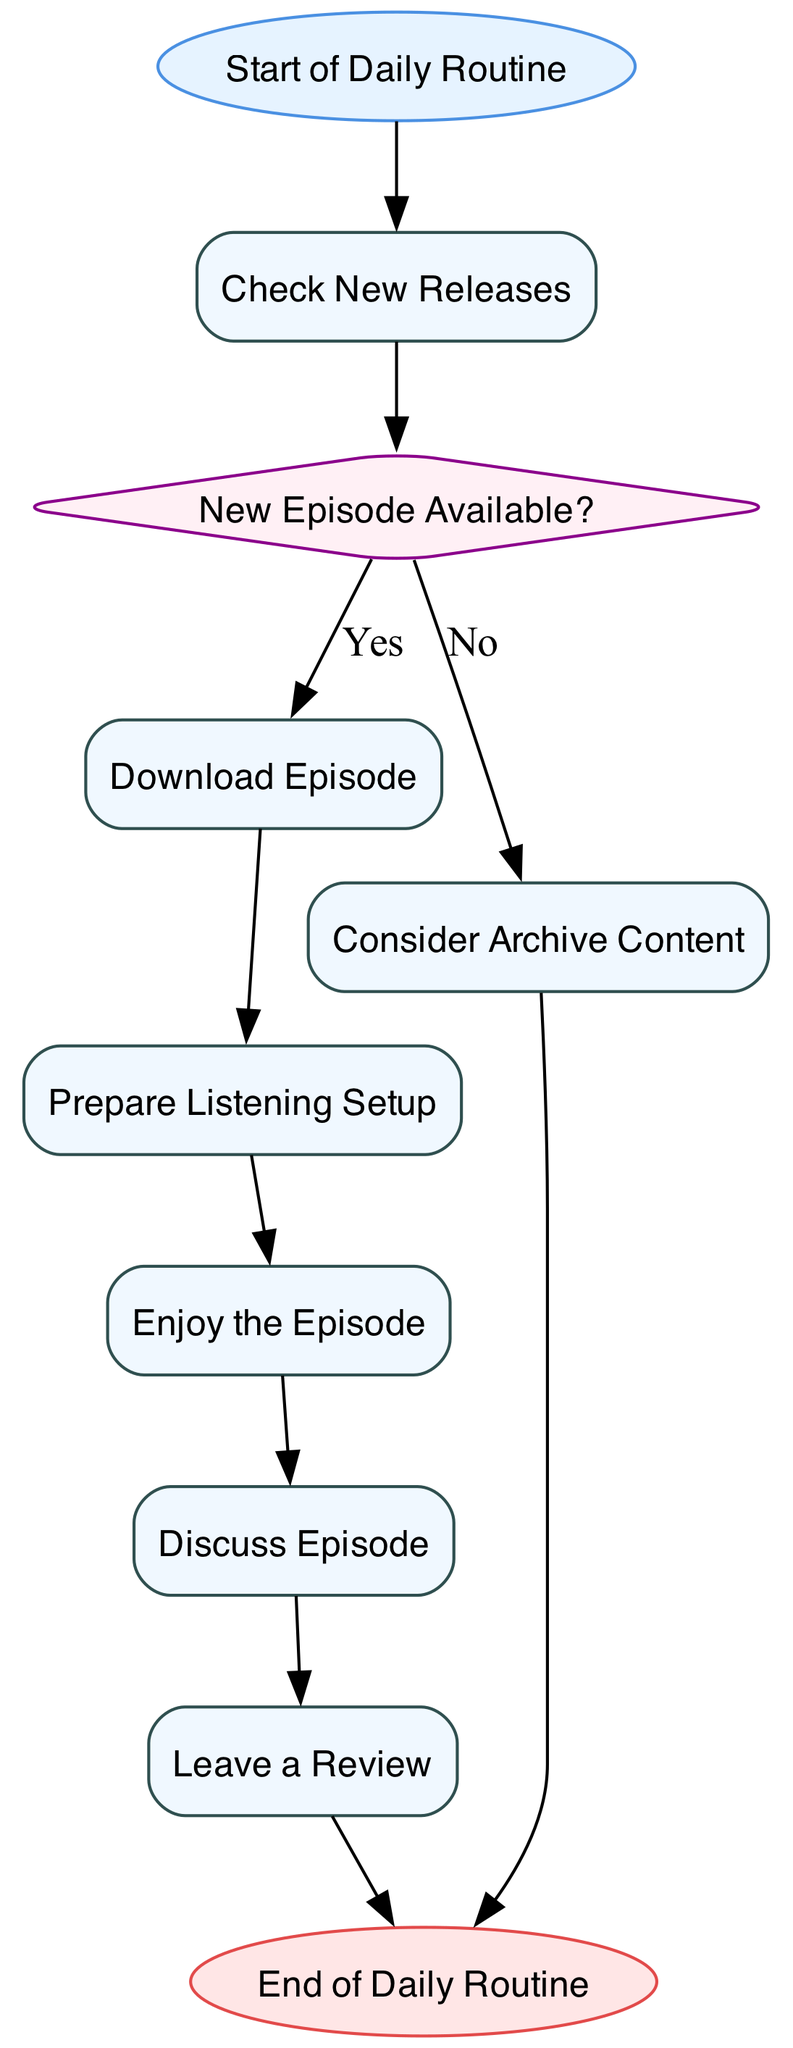What is the first action in the daily routine? The diagram starts with the first action node labeled "Check New Releases," which follows the start node labeled "Start of Daily Routine."
Answer: Check New Releases How many action nodes are present in the diagram? The diagram includes five action nodes: "Check New Releases," "Download Episode," "Prepare Listening Setup," "Enjoy the Episode," and "Discuss Episode."
Answer: Five What does the diagram indicate if there is no new episode available? According to the diagram, if "New Episode Available?" is answered with "No," the next action is to "Consider Archive Content," before eventually proceeding to the end of the flow.
Answer: Consider Archive Content Which node leads to the end of the daily routine? The last node that leads to the end of the daily routine is "Leave a Review," which is directly followed by the end node labeled "End of Daily Routine."
Answer: Leave a Review What type of node is "New Episode Available?" The "New Episode Available?" node is a decision node, which is indicated by its diamond shape and the two options for its outcome.
Answer: Decision What is the last action performed before the end of the routine? The last action performed in the routine, just before reaching the end node, is "Leave a Review." This indicates that the listener provides feedback after discussing the episode.
Answer: Leave a Review If a new episode is available, what follows after "Download Episode"? If a new episode is available, the subsequent action after "Download Episode" is "Prepare Listening Setup," where the listener gets ready to enjoy the downloaded episode.
Answer: Prepare Listening Setup How does the flow of the diagram proceed if both new episodes are not available and archive content is considered? If no new episode is available, the flow leads from the decision node "New Episode Available?" to the action node "Consider Archive Content," and then it proceeds to the end of the routine.
Answer: End of Routine 